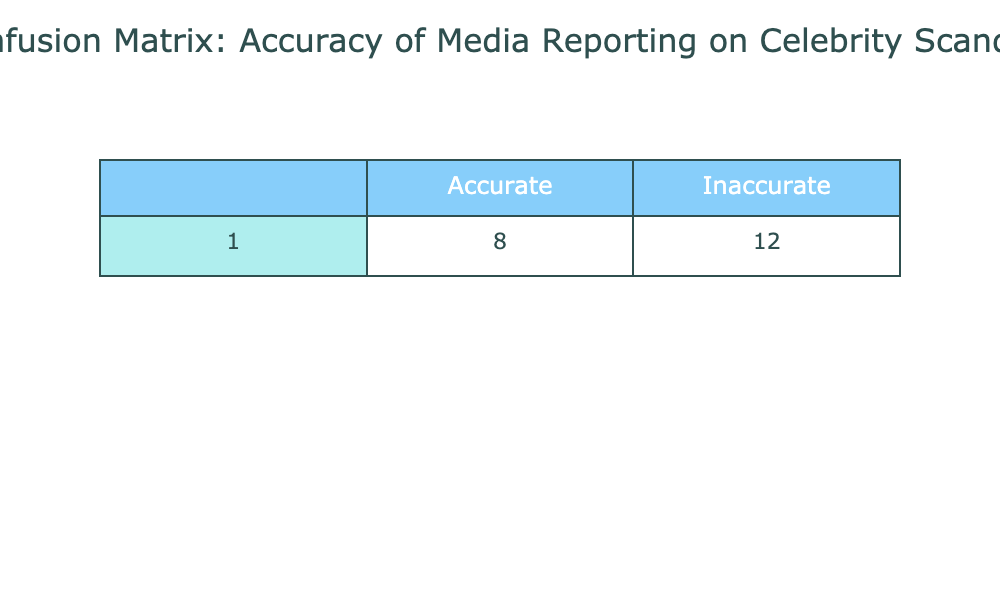What is the total number of accurate predictions? To find the total number of accurate predictions, we add the values in the "Accurate" row. This gives us 15 (Accurate and Accurate) + 8 (Inaccurate and Accurate) = 23.
Answer: 23 What is the total number of inaccurate predictions? The total number of inaccurate predictions can be found by adding the values in the "Inaccurate" row. This gives us 5 (Accurate and Inaccurate) + 12 (Inaccurate and Inaccurate) = 17.
Answer: 17 How many predictions were made overall? To find the total number of predictions, we can add all the values in the table. This gives us 15 + 5 + 8 + 12 = 40.
Answer: 40 Is the number of accurate predictions greater than the number of inaccurate predictions? The number of accurate predictions is 23, and the number of inaccurate predictions is 17. Since 23 is greater than 17, the statement is true.
Answer: Yes What is the ratio of accurate predictions to inaccurate predictions? To find the ratio, we divide the total number of accurate predictions (23) by the total number of inaccurate predictions (17). This gives a ratio of 23:17.
Answer: 23:17 What is the difference between the counts of accurate and inaccurate predictions? We find the difference by subtracting the total number of inaccurate predictions (17) from the total number of accurate predictions (23), which results in 23 - 17 = 6.
Answer: 6 What percentage of the predictions were inaccurate? The percentage of inaccurate predictions is calculated by taking the total number of inaccurate predictions (17) and dividing it by the total number of predictions (40), then multiplying by 100. This gives (17/40) * 100 = 42.5%.
Answer: 42.5% If a new prediction is made, what is the likelihood it will be accurate based on the table? To find the likelihood of an accurate prediction, we can take the total number of accurate predictions (23) and divide it by the overall total of predictions (40). The probability is 23/40 = 0.575 or 57.5%.
Answer: 57.5% How many more inaccurate predictions could be made before reaching the total of accurate predictions? To determine how many more inaccurate predictions could be made, we subtract the number of inaccurate predictions (17) from the number of accurate predictions (23), resulting in 23 - 17 = 6.
Answer: 6 